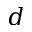<formula> <loc_0><loc_0><loc_500><loc_500>d</formula> 